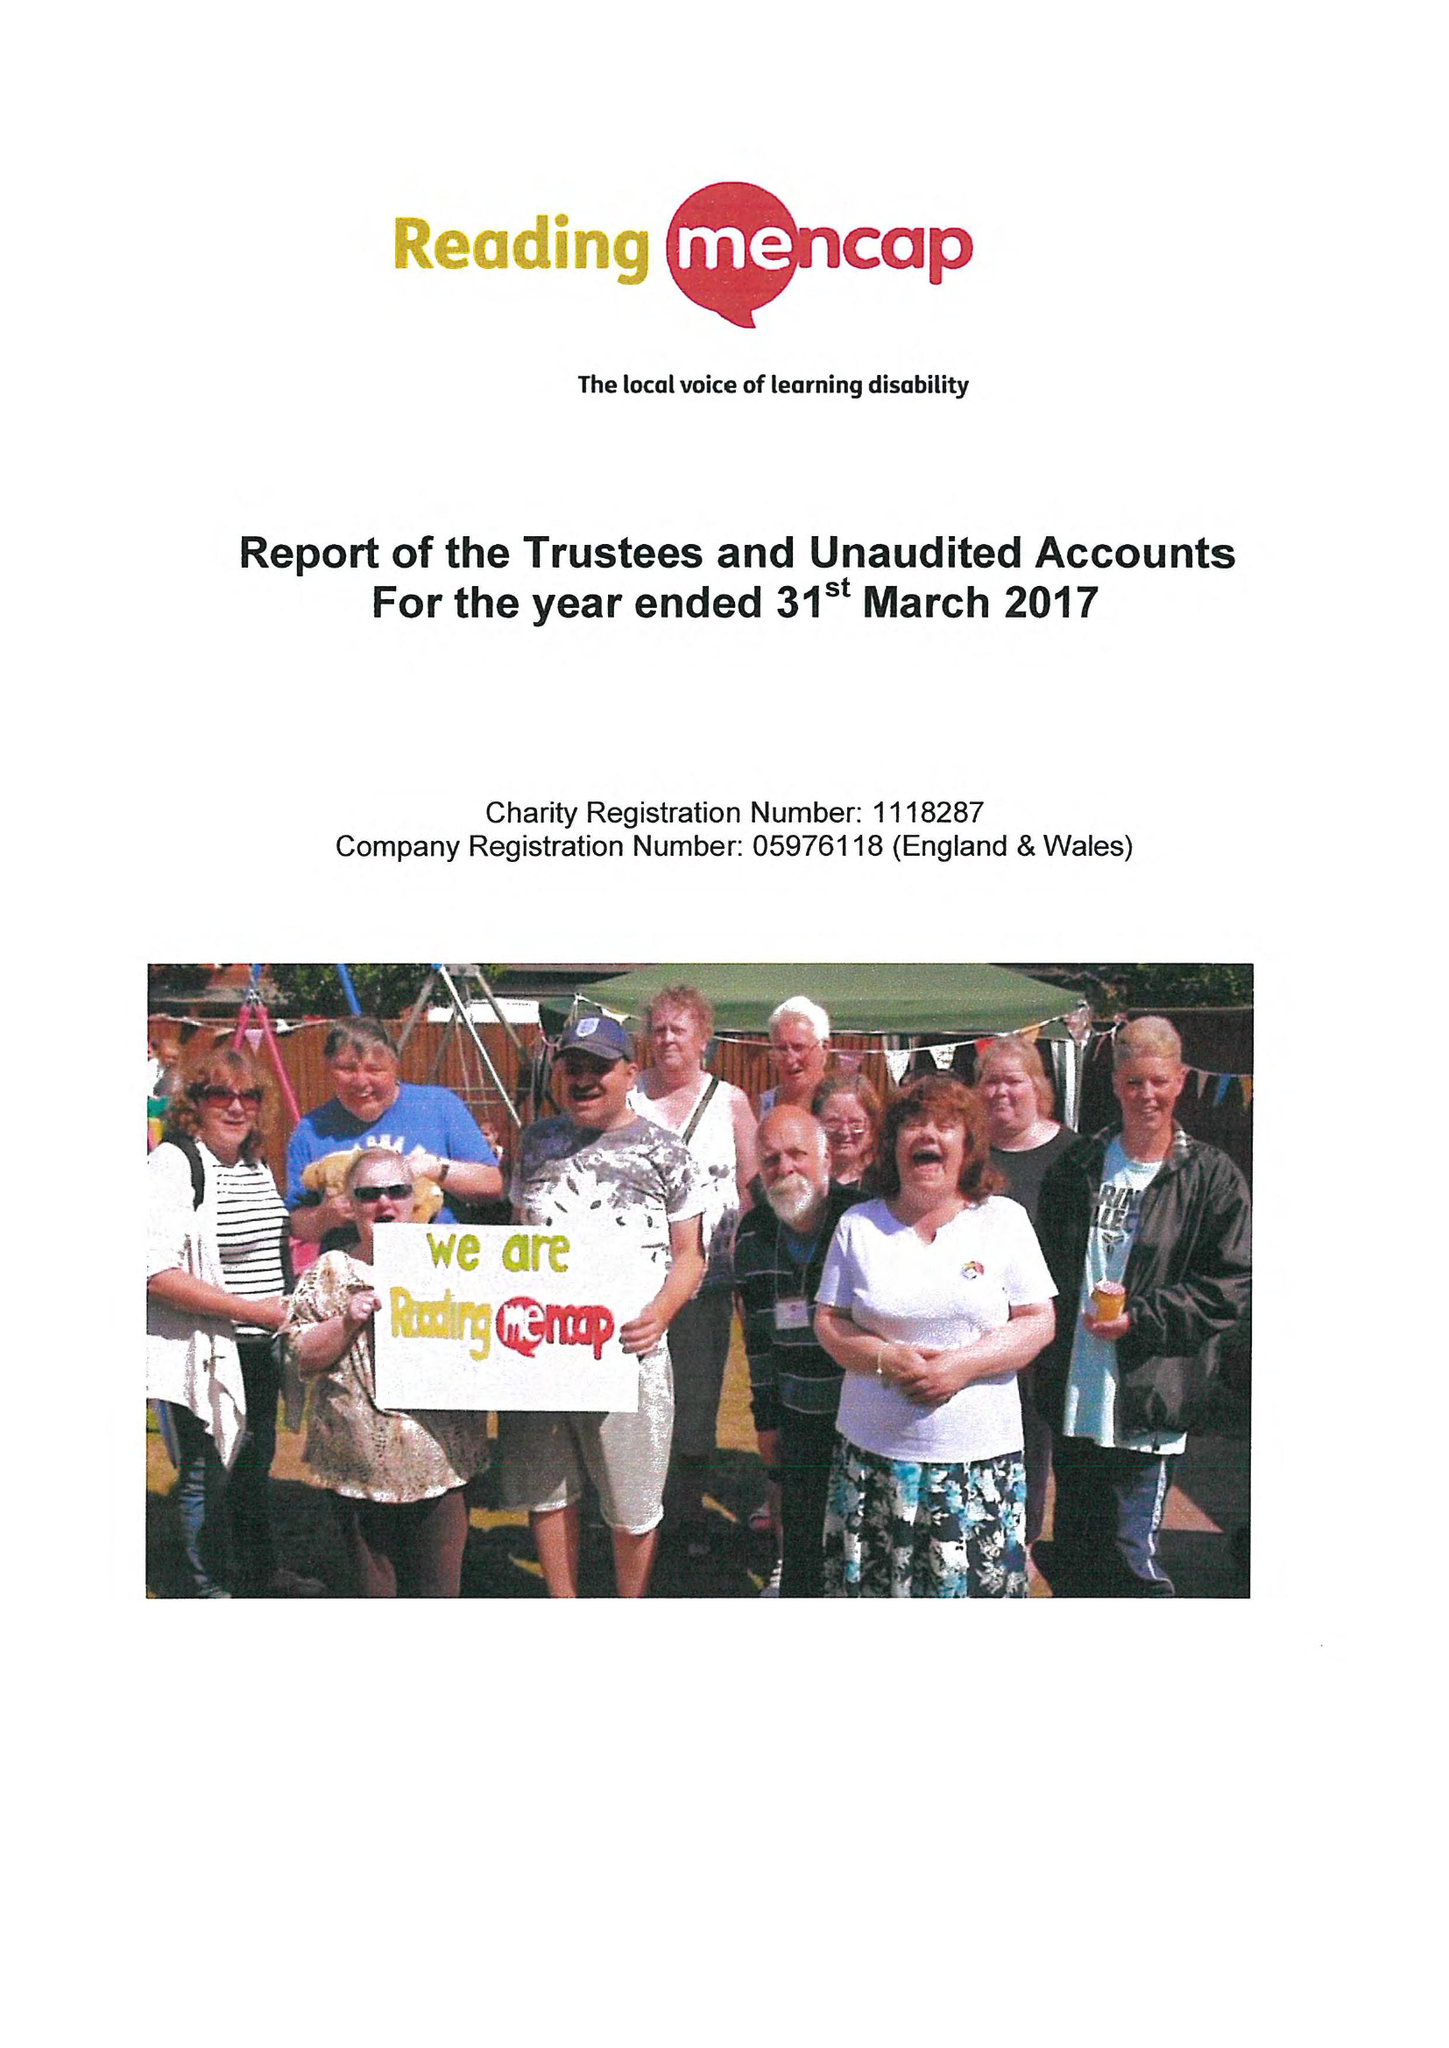What is the value for the address__street_line?
Answer the question using a single word or phrase. 21 ALEXANDRA ROAD 